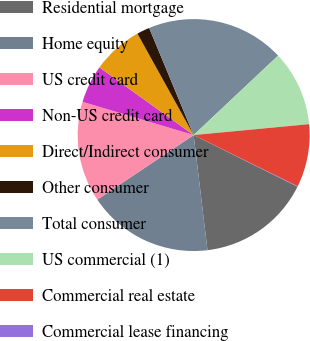Convert chart. <chart><loc_0><loc_0><loc_500><loc_500><pie_chart><fcel>Residential mortgage<fcel>Home equity<fcel>US credit card<fcel>Non-US credit card<fcel>Direct/Indirect consumer<fcel>Other consumer<fcel>Total consumer<fcel>US commercial (1)<fcel>Commercial real estate<fcel>Commercial lease financing<nl><fcel>15.76%<fcel>17.51%<fcel>14.02%<fcel>5.29%<fcel>7.03%<fcel>1.79%<fcel>19.25%<fcel>10.52%<fcel>8.78%<fcel>0.05%<nl></chart> 